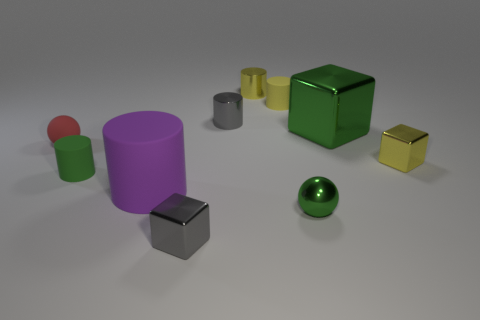Subtract all small metallic cubes. How many cubes are left? 1 Subtract 5 cylinders. How many cylinders are left? 0 Subtract all green spheres. How many spheres are left? 1 Subtract all blocks. How many objects are left? 7 Subtract all purple spheres. How many gray blocks are left? 1 Subtract all red things. Subtract all rubber things. How many objects are left? 5 Add 9 tiny metal spheres. How many tiny metal spheres are left? 10 Add 3 tiny green matte cylinders. How many tiny green matte cylinders exist? 4 Subtract 1 red spheres. How many objects are left? 9 Subtract all cyan cylinders. Subtract all purple balls. How many cylinders are left? 5 